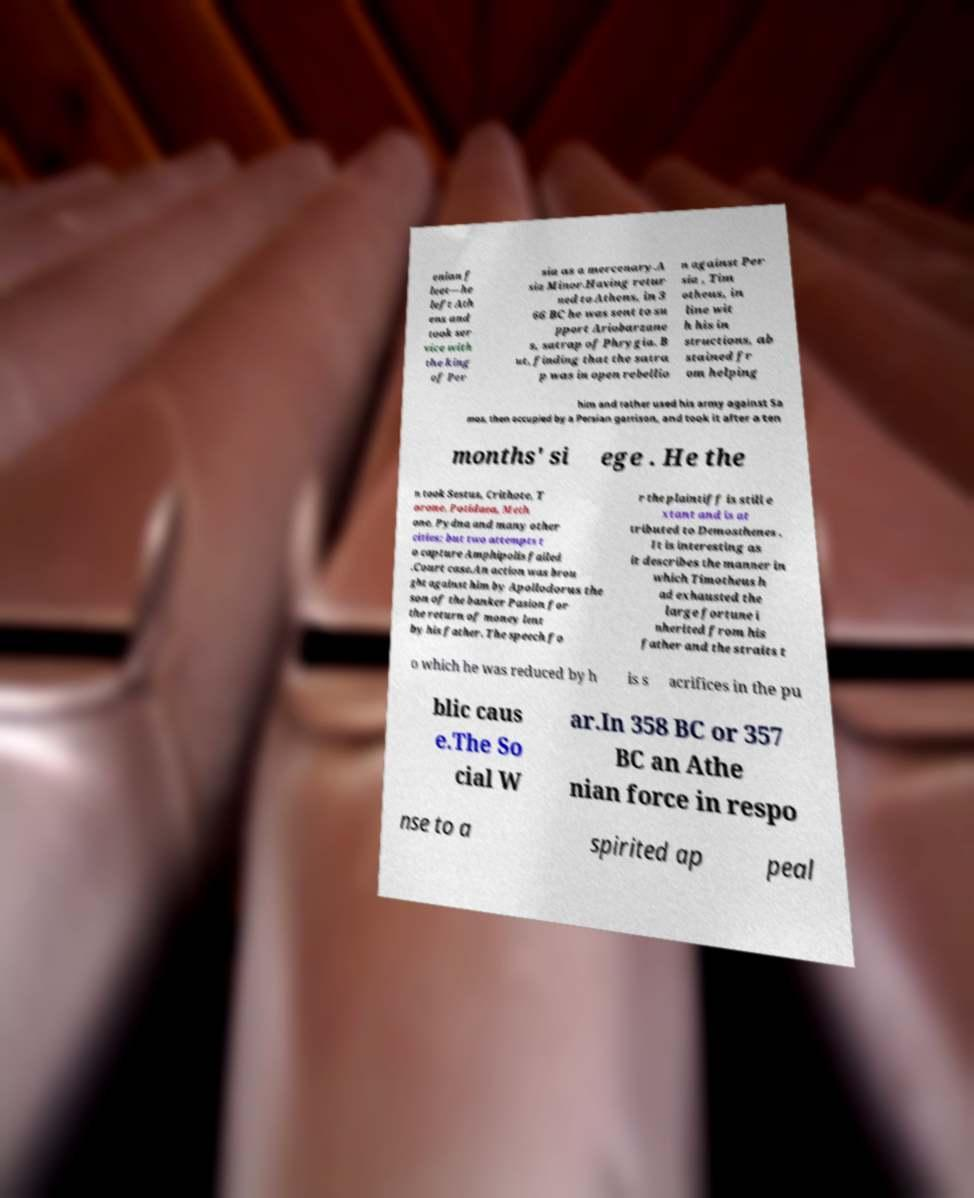Can you accurately transcribe the text from the provided image for me? enian f leet—he left Ath ens and took ser vice with the king of Per sia as a mercenary.A sia Minor.Having retur ned to Athens, in 3 66 BC he was sent to su pport Ariobarzane s, satrap of Phrygia. B ut, finding that the satra p was in open rebellio n against Per sia , Tim otheus, in line wit h his in structions, ab stained fr om helping him and rather used his army against Sa mos, then occupied by a Persian garrison, and took it after a ten months' si ege . He the n took Sestus, Crithote, T orone, Potidaea, Meth one, Pydna and many other cities; but two attempts t o capture Amphipolis failed .Court case.An action was brou ght against him by Apollodorus the son of the banker Pasion for the return of money lent by his father. The speech fo r the plaintiff is still e xtant and is at tributed to Demosthenes . It is interesting as it describes the manner in which Timotheus h ad exhausted the large fortune i nherited from his father and the straits t o which he was reduced by h is s acrifices in the pu blic caus e.The So cial W ar.In 358 BC or 357 BC an Athe nian force in respo nse to a spirited ap peal 